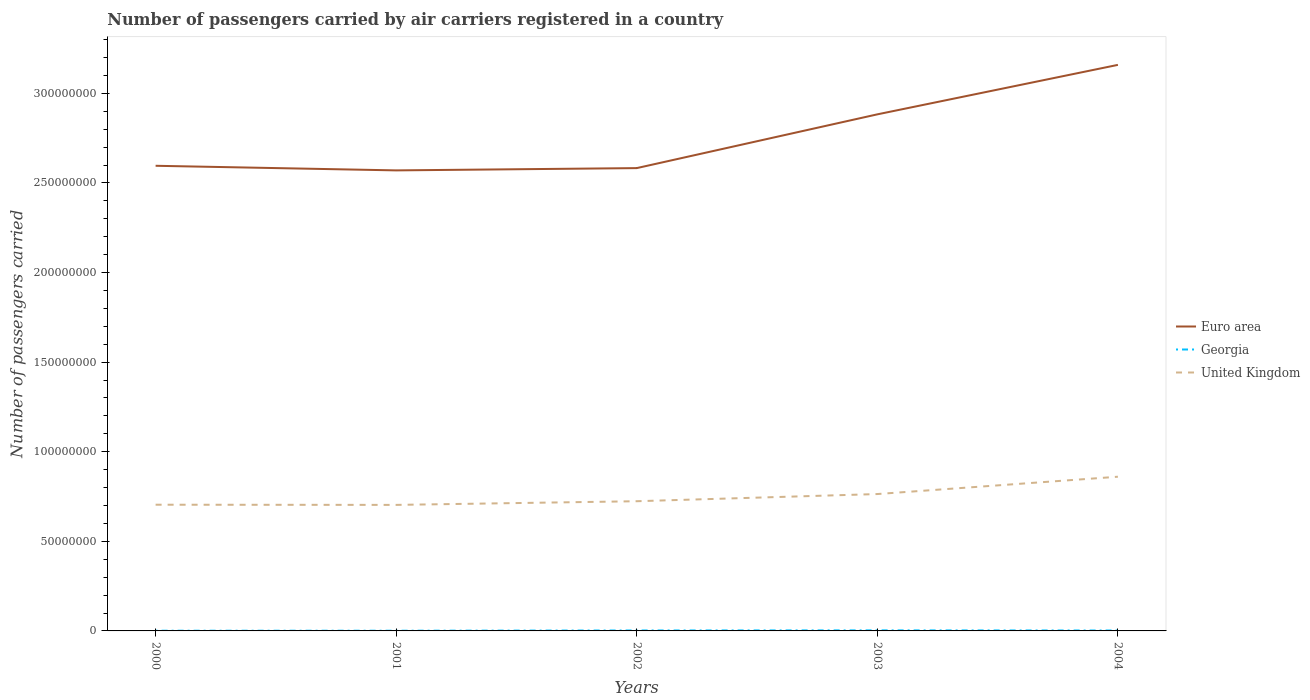How many different coloured lines are there?
Your answer should be very brief. 3. Is the number of lines equal to the number of legend labels?
Offer a terse response. Yes. Across all years, what is the maximum number of passengers carried by air carriers in United Kingdom?
Provide a succinct answer. 7.03e+07. In which year was the number of passengers carried by air carriers in Euro area maximum?
Your answer should be very brief. 2001. What is the total number of passengers carried by air carriers in Georgia in the graph?
Offer a very short reply. -1.18e+05. What is the difference between the highest and the second highest number of passengers carried by air carriers in Georgia?
Give a very brief answer. 1.93e+05. How many lines are there?
Ensure brevity in your answer.  3. How many years are there in the graph?
Offer a terse response. 5. Does the graph contain grids?
Your answer should be compact. No. Where does the legend appear in the graph?
Your answer should be compact. Center right. How are the legend labels stacked?
Your answer should be compact. Vertical. What is the title of the graph?
Provide a succinct answer. Number of passengers carried by air carriers registered in a country. Does "Iran" appear as one of the legend labels in the graph?
Your response must be concise. No. What is the label or title of the Y-axis?
Ensure brevity in your answer.  Number of passengers carried. What is the Number of passengers carried in Euro area in 2000?
Offer a very short reply. 2.60e+08. What is the Number of passengers carried of Georgia in 2000?
Keep it short and to the point. 1.18e+05. What is the Number of passengers carried in United Kingdom in 2000?
Your response must be concise. 7.04e+07. What is the Number of passengers carried of Euro area in 2001?
Provide a succinct answer. 2.57e+08. What is the Number of passengers carried of Georgia in 2001?
Keep it short and to the point. 1.11e+05. What is the Number of passengers carried in United Kingdom in 2001?
Provide a succinct answer. 7.03e+07. What is the Number of passengers carried in Euro area in 2002?
Offer a very short reply. 2.58e+08. What is the Number of passengers carried of Georgia in 2002?
Offer a terse response. 2.47e+05. What is the Number of passengers carried in United Kingdom in 2002?
Offer a very short reply. 7.24e+07. What is the Number of passengers carried of Euro area in 2003?
Ensure brevity in your answer.  2.88e+08. What is the Number of passengers carried of Georgia in 2003?
Keep it short and to the point. 3.04e+05. What is the Number of passengers carried in United Kingdom in 2003?
Make the answer very short. 7.64e+07. What is the Number of passengers carried in Euro area in 2004?
Give a very brief answer. 3.16e+08. What is the Number of passengers carried of Georgia in 2004?
Your answer should be very brief. 2.29e+05. What is the Number of passengers carried of United Kingdom in 2004?
Provide a short and direct response. 8.61e+07. Across all years, what is the maximum Number of passengers carried of Euro area?
Your answer should be compact. 3.16e+08. Across all years, what is the maximum Number of passengers carried of Georgia?
Make the answer very short. 3.04e+05. Across all years, what is the maximum Number of passengers carried of United Kingdom?
Ensure brevity in your answer.  8.61e+07. Across all years, what is the minimum Number of passengers carried in Euro area?
Keep it short and to the point. 2.57e+08. Across all years, what is the minimum Number of passengers carried of Georgia?
Keep it short and to the point. 1.11e+05. Across all years, what is the minimum Number of passengers carried in United Kingdom?
Offer a very short reply. 7.03e+07. What is the total Number of passengers carried in Euro area in the graph?
Keep it short and to the point. 1.38e+09. What is the total Number of passengers carried of Georgia in the graph?
Ensure brevity in your answer.  1.01e+06. What is the total Number of passengers carried of United Kingdom in the graph?
Your answer should be compact. 3.76e+08. What is the difference between the Number of passengers carried of Euro area in 2000 and that in 2001?
Offer a very short reply. 2.57e+06. What is the difference between the Number of passengers carried in Georgia in 2000 and that in 2001?
Your answer should be compact. 6721. What is the difference between the Number of passengers carried in United Kingdom in 2000 and that in 2001?
Your response must be concise. 1.04e+05. What is the difference between the Number of passengers carried of Euro area in 2000 and that in 2002?
Make the answer very short. 1.29e+06. What is the difference between the Number of passengers carried of Georgia in 2000 and that in 2002?
Provide a succinct answer. -1.29e+05. What is the difference between the Number of passengers carried in United Kingdom in 2000 and that in 2002?
Provide a short and direct response. -1.95e+06. What is the difference between the Number of passengers carried of Euro area in 2000 and that in 2003?
Offer a very short reply. -2.87e+07. What is the difference between the Number of passengers carried in Georgia in 2000 and that in 2003?
Give a very brief answer. -1.86e+05. What is the difference between the Number of passengers carried in United Kingdom in 2000 and that in 2003?
Offer a terse response. -5.95e+06. What is the difference between the Number of passengers carried in Euro area in 2000 and that in 2004?
Keep it short and to the point. -5.63e+07. What is the difference between the Number of passengers carried of Georgia in 2000 and that in 2004?
Your answer should be very brief. -1.11e+05. What is the difference between the Number of passengers carried of United Kingdom in 2000 and that in 2004?
Give a very brief answer. -1.56e+07. What is the difference between the Number of passengers carried in Euro area in 2001 and that in 2002?
Provide a succinct answer. -1.28e+06. What is the difference between the Number of passengers carried in Georgia in 2001 and that in 2002?
Keep it short and to the point. -1.36e+05. What is the difference between the Number of passengers carried in United Kingdom in 2001 and that in 2002?
Make the answer very short. -2.05e+06. What is the difference between the Number of passengers carried of Euro area in 2001 and that in 2003?
Give a very brief answer. -3.13e+07. What is the difference between the Number of passengers carried in Georgia in 2001 and that in 2003?
Offer a very short reply. -1.93e+05. What is the difference between the Number of passengers carried of United Kingdom in 2001 and that in 2003?
Offer a terse response. -6.06e+06. What is the difference between the Number of passengers carried in Euro area in 2001 and that in 2004?
Your answer should be compact. -5.89e+07. What is the difference between the Number of passengers carried of Georgia in 2001 and that in 2004?
Offer a very short reply. -1.18e+05. What is the difference between the Number of passengers carried of United Kingdom in 2001 and that in 2004?
Your answer should be compact. -1.57e+07. What is the difference between the Number of passengers carried of Euro area in 2002 and that in 2003?
Provide a short and direct response. -3.00e+07. What is the difference between the Number of passengers carried of Georgia in 2002 and that in 2003?
Provide a short and direct response. -5.72e+04. What is the difference between the Number of passengers carried of United Kingdom in 2002 and that in 2003?
Provide a succinct answer. -4.01e+06. What is the difference between the Number of passengers carried of Euro area in 2002 and that in 2004?
Keep it short and to the point. -5.76e+07. What is the difference between the Number of passengers carried of Georgia in 2002 and that in 2004?
Give a very brief answer. 1.80e+04. What is the difference between the Number of passengers carried in United Kingdom in 2002 and that in 2004?
Your answer should be compact. -1.37e+07. What is the difference between the Number of passengers carried in Euro area in 2003 and that in 2004?
Your answer should be very brief. -2.76e+07. What is the difference between the Number of passengers carried in Georgia in 2003 and that in 2004?
Your answer should be very brief. 7.52e+04. What is the difference between the Number of passengers carried in United Kingdom in 2003 and that in 2004?
Keep it short and to the point. -9.67e+06. What is the difference between the Number of passengers carried in Euro area in 2000 and the Number of passengers carried in Georgia in 2001?
Make the answer very short. 2.59e+08. What is the difference between the Number of passengers carried in Euro area in 2000 and the Number of passengers carried in United Kingdom in 2001?
Your response must be concise. 1.89e+08. What is the difference between the Number of passengers carried in Georgia in 2000 and the Number of passengers carried in United Kingdom in 2001?
Offer a terse response. -7.02e+07. What is the difference between the Number of passengers carried in Euro area in 2000 and the Number of passengers carried in Georgia in 2002?
Keep it short and to the point. 2.59e+08. What is the difference between the Number of passengers carried in Euro area in 2000 and the Number of passengers carried in United Kingdom in 2002?
Make the answer very short. 1.87e+08. What is the difference between the Number of passengers carried in Georgia in 2000 and the Number of passengers carried in United Kingdom in 2002?
Offer a terse response. -7.23e+07. What is the difference between the Number of passengers carried in Euro area in 2000 and the Number of passengers carried in Georgia in 2003?
Offer a terse response. 2.59e+08. What is the difference between the Number of passengers carried in Euro area in 2000 and the Number of passengers carried in United Kingdom in 2003?
Your response must be concise. 1.83e+08. What is the difference between the Number of passengers carried in Georgia in 2000 and the Number of passengers carried in United Kingdom in 2003?
Your answer should be very brief. -7.63e+07. What is the difference between the Number of passengers carried of Euro area in 2000 and the Number of passengers carried of Georgia in 2004?
Provide a succinct answer. 2.59e+08. What is the difference between the Number of passengers carried of Euro area in 2000 and the Number of passengers carried of United Kingdom in 2004?
Ensure brevity in your answer.  1.74e+08. What is the difference between the Number of passengers carried in Georgia in 2000 and the Number of passengers carried in United Kingdom in 2004?
Your answer should be compact. -8.59e+07. What is the difference between the Number of passengers carried of Euro area in 2001 and the Number of passengers carried of Georgia in 2002?
Provide a succinct answer. 2.57e+08. What is the difference between the Number of passengers carried in Euro area in 2001 and the Number of passengers carried in United Kingdom in 2002?
Your answer should be compact. 1.85e+08. What is the difference between the Number of passengers carried of Georgia in 2001 and the Number of passengers carried of United Kingdom in 2002?
Give a very brief answer. -7.23e+07. What is the difference between the Number of passengers carried of Euro area in 2001 and the Number of passengers carried of Georgia in 2003?
Ensure brevity in your answer.  2.57e+08. What is the difference between the Number of passengers carried in Euro area in 2001 and the Number of passengers carried in United Kingdom in 2003?
Offer a terse response. 1.81e+08. What is the difference between the Number of passengers carried of Georgia in 2001 and the Number of passengers carried of United Kingdom in 2003?
Offer a terse response. -7.63e+07. What is the difference between the Number of passengers carried of Euro area in 2001 and the Number of passengers carried of Georgia in 2004?
Keep it short and to the point. 2.57e+08. What is the difference between the Number of passengers carried in Euro area in 2001 and the Number of passengers carried in United Kingdom in 2004?
Your answer should be compact. 1.71e+08. What is the difference between the Number of passengers carried in Georgia in 2001 and the Number of passengers carried in United Kingdom in 2004?
Offer a terse response. -8.59e+07. What is the difference between the Number of passengers carried of Euro area in 2002 and the Number of passengers carried of Georgia in 2003?
Your response must be concise. 2.58e+08. What is the difference between the Number of passengers carried of Euro area in 2002 and the Number of passengers carried of United Kingdom in 2003?
Offer a terse response. 1.82e+08. What is the difference between the Number of passengers carried in Georgia in 2002 and the Number of passengers carried in United Kingdom in 2003?
Provide a short and direct response. -7.61e+07. What is the difference between the Number of passengers carried in Euro area in 2002 and the Number of passengers carried in Georgia in 2004?
Keep it short and to the point. 2.58e+08. What is the difference between the Number of passengers carried in Euro area in 2002 and the Number of passengers carried in United Kingdom in 2004?
Provide a succinct answer. 1.72e+08. What is the difference between the Number of passengers carried in Georgia in 2002 and the Number of passengers carried in United Kingdom in 2004?
Your answer should be very brief. -8.58e+07. What is the difference between the Number of passengers carried in Euro area in 2003 and the Number of passengers carried in Georgia in 2004?
Give a very brief answer. 2.88e+08. What is the difference between the Number of passengers carried of Euro area in 2003 and the Number of passengers carried of United Kingdom in 2004?
Keep it short and to the point. 2.02e+08. What is the difference between the Number of passengers carried in Georgia in 2003 and the Number of passengers carried in United Kingdom in 2004?
Your answer should be compact. -8.58e+07. What is the average Number of passengers carried in Euro area per year?
Your response must be concise. 2.76e+08. What is the average Number of passengers carried in Georgia per year?
Keep it short and to the point. 2.01e+05. What is the average Number of passengers carried in United Kingdom per year?
Your answer should be very brief. 7.51e+07. In the year 2000, what is the difference between the Number of passengers carried in Euro area and Number of passengers carried in Georgia?
Keep it short and to the point. 2.59e+08. In the year 2000, what is the difference between the Number of passengers carried of Euro area and Number of passengers carried of United Kingdom?
Offer a terse response. 1.89e+08. In the year 2000, what is the difference between the Number of passengers carried of Georgia and Number of passengers carried of United Kingdom?
Provide a short and direct response. -7.03e+07. In the year 2001, what is the difference between the Number of passengers carried of Euro area and Number of passengers carried of Georgia?
Provide a succinct answer. 2.57e+08. In the year 2001, what is the difference between the Number of passengers carried of Euro area and Number of passengers carried of United Kingdom?
Ensure brevity in your answer.  1.87e+08. In the year 2001, what is the difference between the Number of passengers carried in Georgia and Number of passengers carried in United Kingdom?
Keep it short and to the point. -7.02e+07. In the year 2002, what is the difference between the Number of passengers carried in Euro area and Number of passengers carried in Georgia?
Ensure brevity in your answer.  2.58e+08. In the year 2002, what is the difference between the Number of passengers carried of Euro area and Number of passengers carried of United Kingdom?
Make the answer very short. 1.86e+08. In the year 2002, what is the difference between the Number of passengers carried in Georgia and Number of passengers carried in United Kingdom?
Ensure brevity in your answer.  -7.21e+07. In the year 2003, what is the difference between the Number of passengers carried of Euro area and Number of passengers carried of Georgia?
Provide a succinct answer. 2.88e+08. In the year 2003, what is the difference between the Number of passengers carried of Euro area and Number of passengers carried of United Kingdom?
Give a very brief answer. 2.12e+08. In the year 2003, what is the difference between the Number of passengers carried of Georgia and Number of passengers carried of United Kingdom?
Offer a very short reply. -7.61e+07. In the year 2004, what is the difference between the Number of passengers carried in Euro area and Number of passengers carried in Georgia?
Provide a succinct answer. 3.16e+08. In the year 2004, what is the difference between the Number of passengers carried of Euro area and Number of passengers carried of United Kingdom?
Make the answer very short. 2.30e+08. In the year 2004, what is the difference between the Number of passengers carried in Georgia and Number of passengers carried in United Kingdom?
Make the answer very short. -8.58e+07. What is the ratio of the Number of passengers carried of Euro area in 2000 to that in 2001?
Your answer should be very brief. 1.01. What is the ratio of the Number of passengers carried of Georgia in 2000 to that in 2001?
Offer a very short reply. 1.06. What is the ratio of the Number of passengers carried in United Kingdom in 2000 to that in 2001?
Your response must be concise. 1. What is the ratio of the Number of passengers carried of Georgia in 2000 to that in 2002?
Ensure brevity in your answer.  0.48. What is the ratio of the Number of passengers carried of United Kingdom in 2000 to that in 2002?
Your answer should be compact. 0.97. What is the ratio of the Number of passengers carried in Euro area in 2000 to that in 2003?
Your answer should be very brief. 0.9. What is the ratio of the Number of passengers carried in Georgia in 2000 to that in 2003?
Ensure brevity in your answer.  0.39. What is the ratio of the Number of passengers carried of United Kingdom in 2000 to that in 2003?
Your response must be concise. 0.92. What is the ratio of the Number of passengers carried of Euro area in 2000 to that in 2004?
Make the answer very short. 0.82. What is the ratio of the Number of passengers carried of Georgia in 2000 to that in 2004?
Provide a short and direct response. 0.51. What is the ratio of the Number of passengers carried in United Kingdom in 2000 to that in 2004?
Ensure brevity in your answer.  0.82. What is the ratio of the Number of passengers carried in Euro area in 2001 to that in 2002?
Offer a very short reply. 1. What is the ratio of the Number of passengers carried of Georgia in 2001 to that in 2002?
Keep it short and to the point. 0.45. What is the ratio of the Number of passengers carried of United Kingdom in 2001 to that in 2002?
Provide a short and direct response. 0.97. What is the ratio of the Number of passengers carried of Euro area in 2001 to that in 2003?
Make the answer very short. 0.89. What is the ratio of the Number of passengers carried in Georgia in 2001 to that in 2003?
Provide a short and direct response. 0.36. What is the ratio of the Number of passengers carried in United Kingdom in 2001 to that in 2003?
Offer a terse response. 0.92. What is the ratio of the Number of passengers carried of Euro area in 2001 to that in 2004?
Provide a succinct answer. 0.81. What is the ratio of the Number of passengers carried of Georgia in 2001 to that in 2004?
Keep it short and to the point. 0.48. What is the ratio of the Number of passengers carried of United Kingdom in 2001 to that in 2004?
Provide a short and direct response. 0.82. What is the ratio of the Number of passengers carried in Euro area in 2002 to that in 2003?
Provide a succinct answer. 0.9. What is the ratio of the Number of passengers carried in Georgia in 2002 to that in 2003?
Your answer should be compact. 0.81. What is the ratio of the Number of passengers carried in United Kingdom in 2002 to that in 2003?
Make the answer very short. 0.95. What is the ratio of the Number of passengers carried of Euro area in 2002 to that in 2004?
Make the answer very short. 0.82. What is the ratio of the Number of passengers carried in Georgia in 2002 to that in 2004?
Offer a very short reply. 1.08. What is the ratio of the Number of passengers carried of United Kingdom in 2002 to that in 2004?
Your answer should be compact. 0.84. What is the ratio of the Number of passengers carried in Euro area in 2003 to that in 2004?
Provide a short and direct response. 0.91. What is the ratio of the Number of passengers carried of Georgia in 2003 to that in 2004?
Make the answer very short. 1.33. What is the ratio of the Number of passengers carried in United Kingdom in 2003 to that in 2004?
Make the answer very short. 0.89. What is the difference between the highest and the second highest Number of passengers carried in Euro area?
Your response must be concise. 2.76e+07. What is the difference between the highest and the second highest Number of passengers carried in Georgia?
Your answer should be compact. 5.72e+04. What is the difference between the highest and the second highest Number of passengers carried of United Kingdom?
Offer a very short reply. 9.67e+06. What is the difference between the highest and the lowest Number of passengers carried in Euro area?
Make the answer very short. 5.89e+07. What is the difference between the highest and the lowest Number of passengers carried of Georgia?
Provide a succinct answer. 1.93e+05. What is the difference between the highest and the lowest Number of passengers carried in United Kingdom?
Make the answer very short. 1.57e+07. 